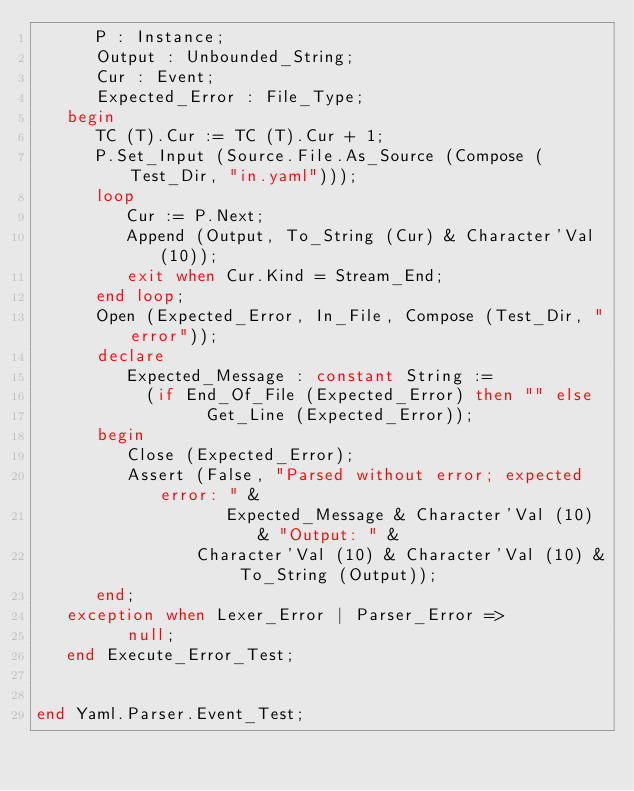Convert code to text. <code><loc_0><loc_0><loc_500><loc_500><_Ada_>      P : Instance;
      Output : Unbounded_String;
      Cur : Event;
      Expected_Error : File_Type;
   begin
      TC (T).Cur := TC (T).Cur + 1;
      P.Set_Input (Source.File.As_Source (Compose (Test_Dir, "in.yaml")));
      loop
         Cur := P.Next;
         Append (Output, To_String (Cur) & Character'Val (10));
         exit when Cur.Kind = Stream_End;
      end loop;
      Open (Expected_Error, In_File, Compose (Test_Dir, "error"));
      declare
         Expected_Message : constant String :=
           (if End_Of_File (Expected_Error) then "" else
                 Get_Line (Expected_Error));
      begin
         Close (Expected_Error);
         Assert (False, "Parsed without error; expected error: " &
                   Expected_Message & Character'Val (10) & "Output: " &
                Character'Val (10) & Character'Val (10) & To_String (Output));
      end;
   exception when Lexer_Error | Parser_Error =>
         null;
   end Execute_Error_Test;


end Yaml.Parser.Event_Test;
</code> 